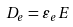Convert formula to latex. <formula><loc_0><loc_0><loc_500><loc_500>D _ { e } = \varepsilon _ { e } E</formula> 